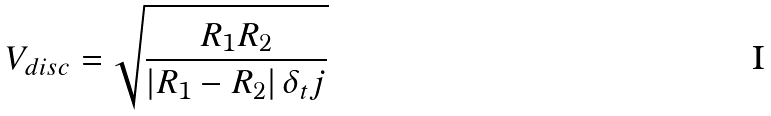Convert formula to latex. <formula><loc_0><loc_0><loc_500><loc_500>V _ { d i s c } = \sqrt { \frac { R _ { 1 } R _ { 2 } } { \left | R _ { 1 } - R _ { 2 } \right | \delta _ { t } j } }</formula> 